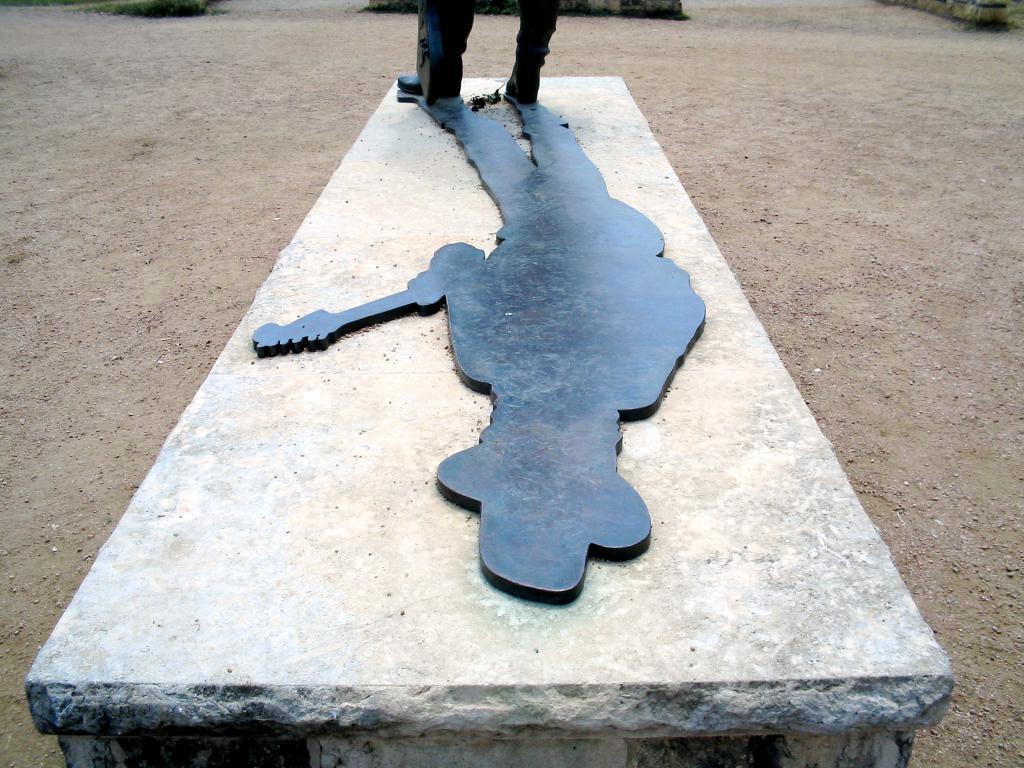In one or two sentences, can you explain what this image depicts? In this image there is a wall. There is a sculpture on the wall. Around it there is the ground. 